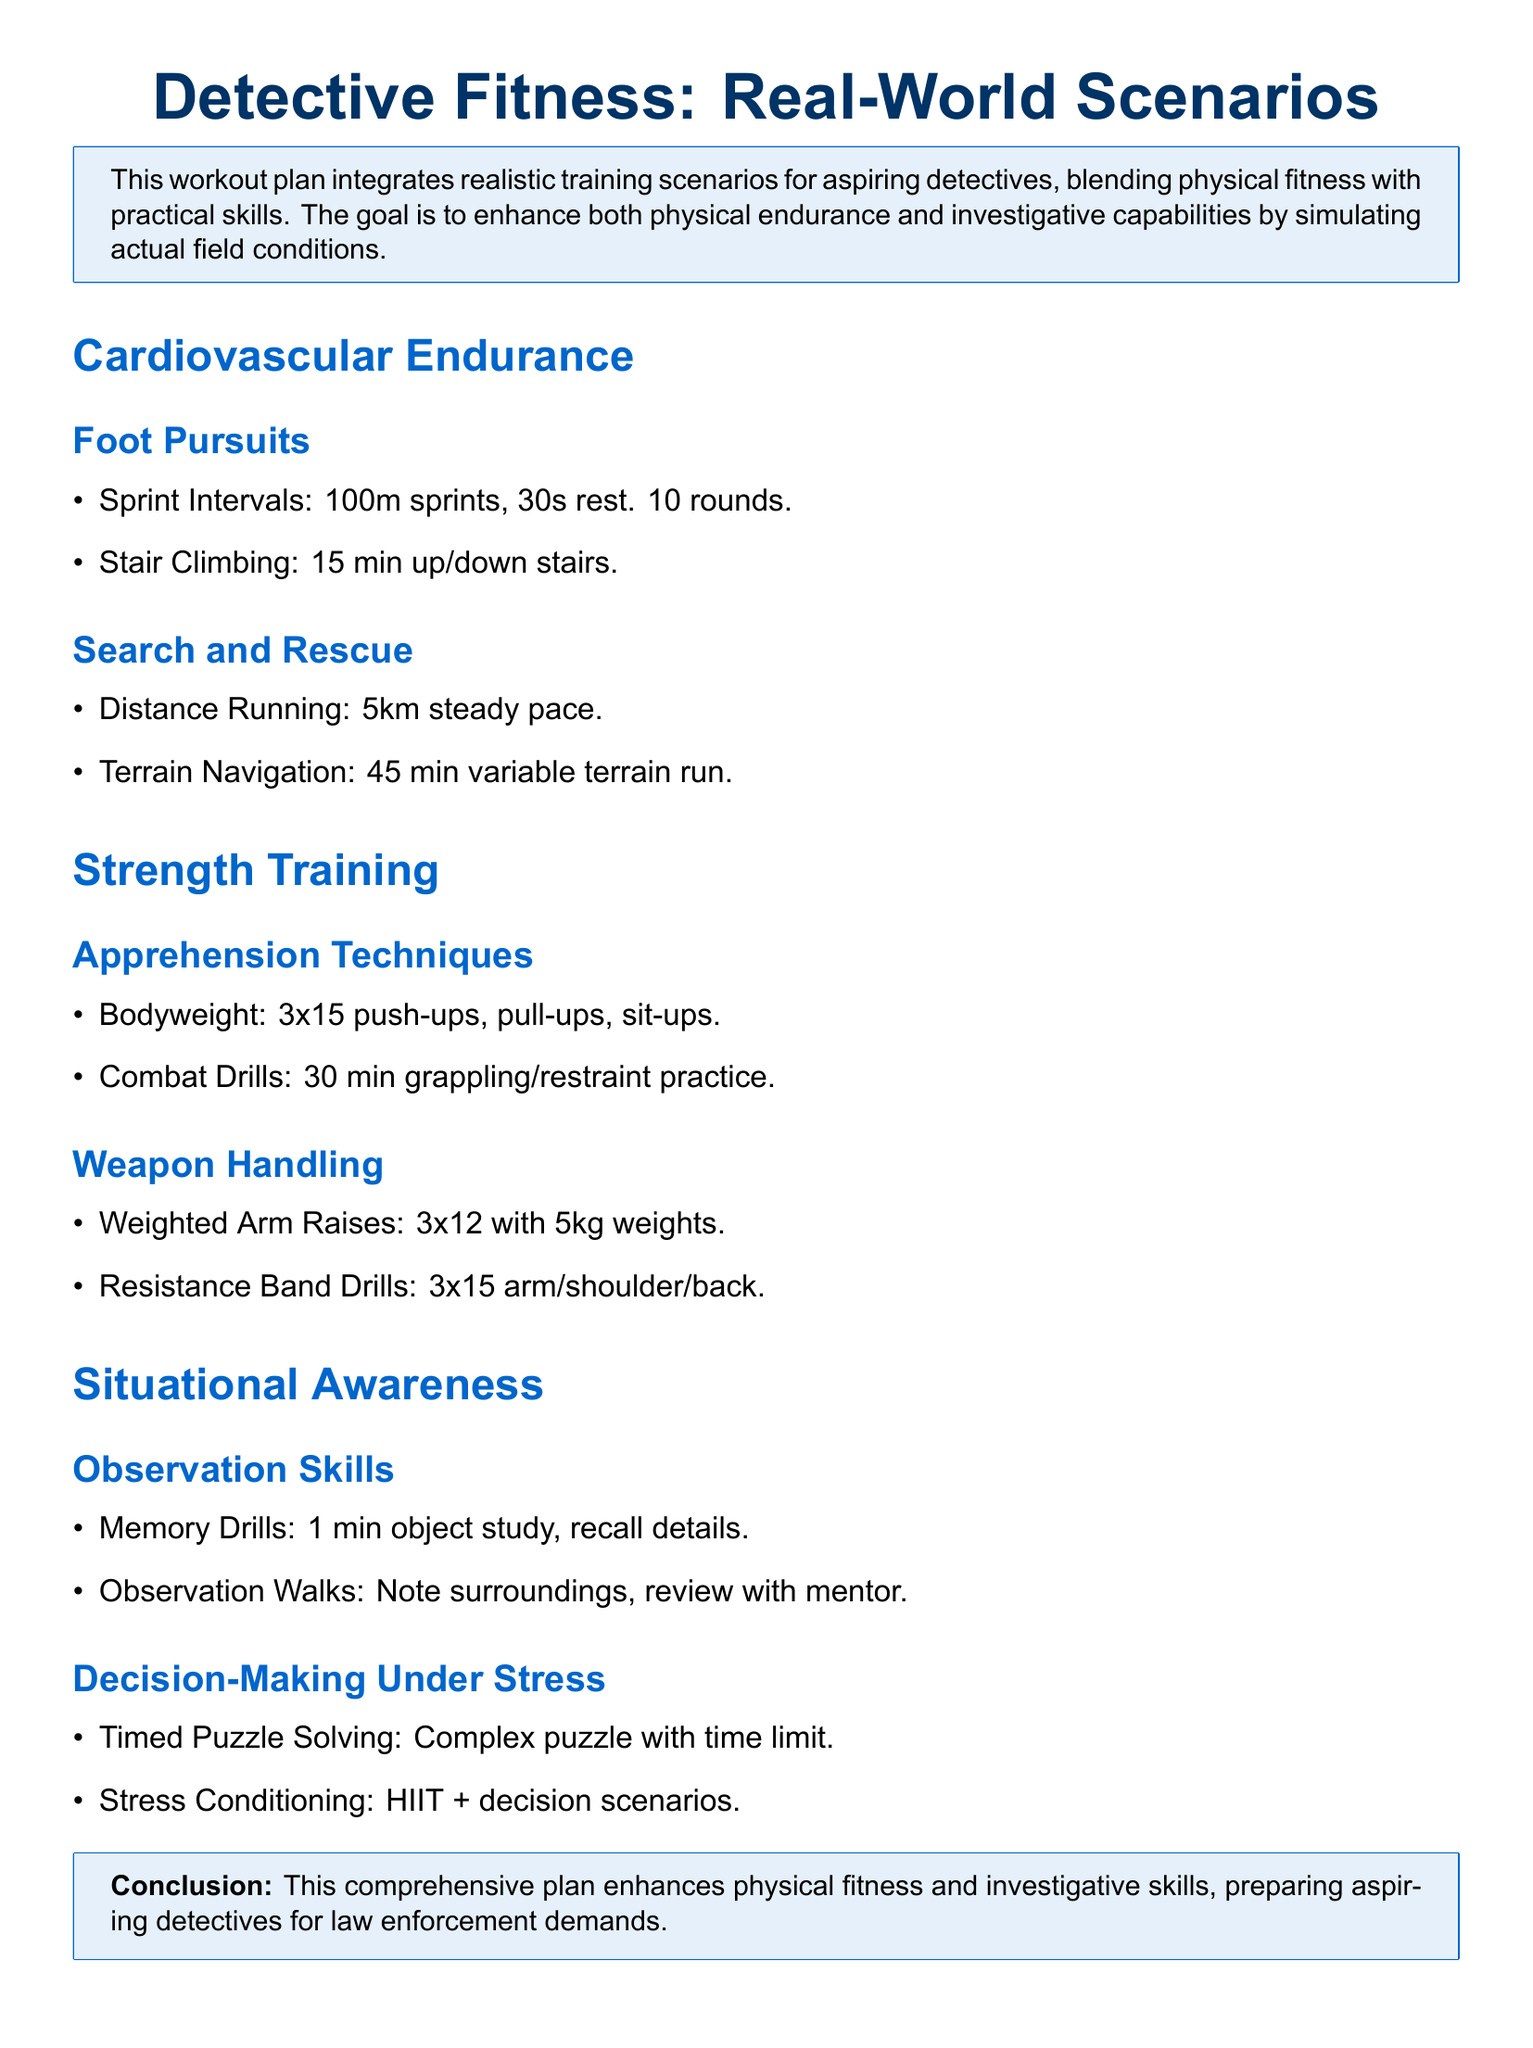What is the primary goal of the workout plan? The goal of the workout plan is to enhance both physical endurance and investigative capabilities by simulating actual field conditions.
Answer: Enhance physical endurance and investigative capabilities How many rounds of sprint intervals are suggested? The document specifies 10 rounds of 100m sprints with 30 seconds of rest.
Answer: 10 rounds What is the duration of the terrain navigation run? The document states that the terrain navigation run should last for 45 minutes.
Answer: 45 min How many push-ups are recommended in the bodyweight section? The recommendation is for 3 sets of 15 push-ups as part of the bodyweight exercises.
Answer: 3x15 What type of drills are included under Weapon Handling? Resistance Band Drills are listed as one of the training activities under Weapon Handling.
Answer: Resistance Band Drills What is one of the decision-making exercises included? The document mentions "Timed Puzzle Solving" as an exercise for decision-making under stress.
Answer: Timed Puzzle Solving What should participants do during Observation Walks? Participants are advised to note their surroundings and review them with a mentor.
Answer: Note surroundings, review with mentor How long should participants practice combat drills? The document indicates that combat drills should be practiced for 30 minutes.
Answer: 30 min What is the focus of the strength training section? The strength training section focuses on Apprehension Techniques and Weapon Handling.
Answer: Apprehension Techniques and Weapon Handling 